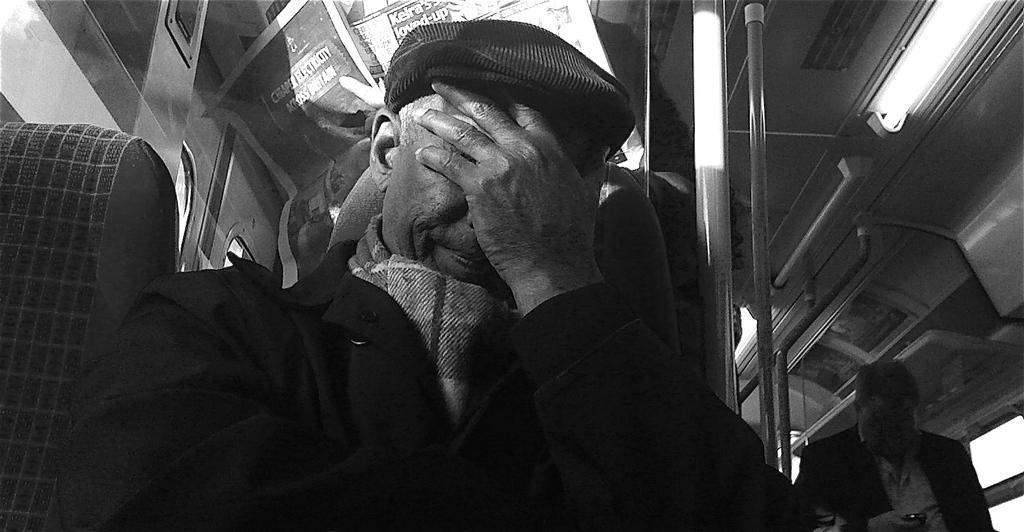How would you summarize this image in a sentence or two? This is a black and white image. This is clicked in a train. There is a person in the middle. There are lights at the top. 